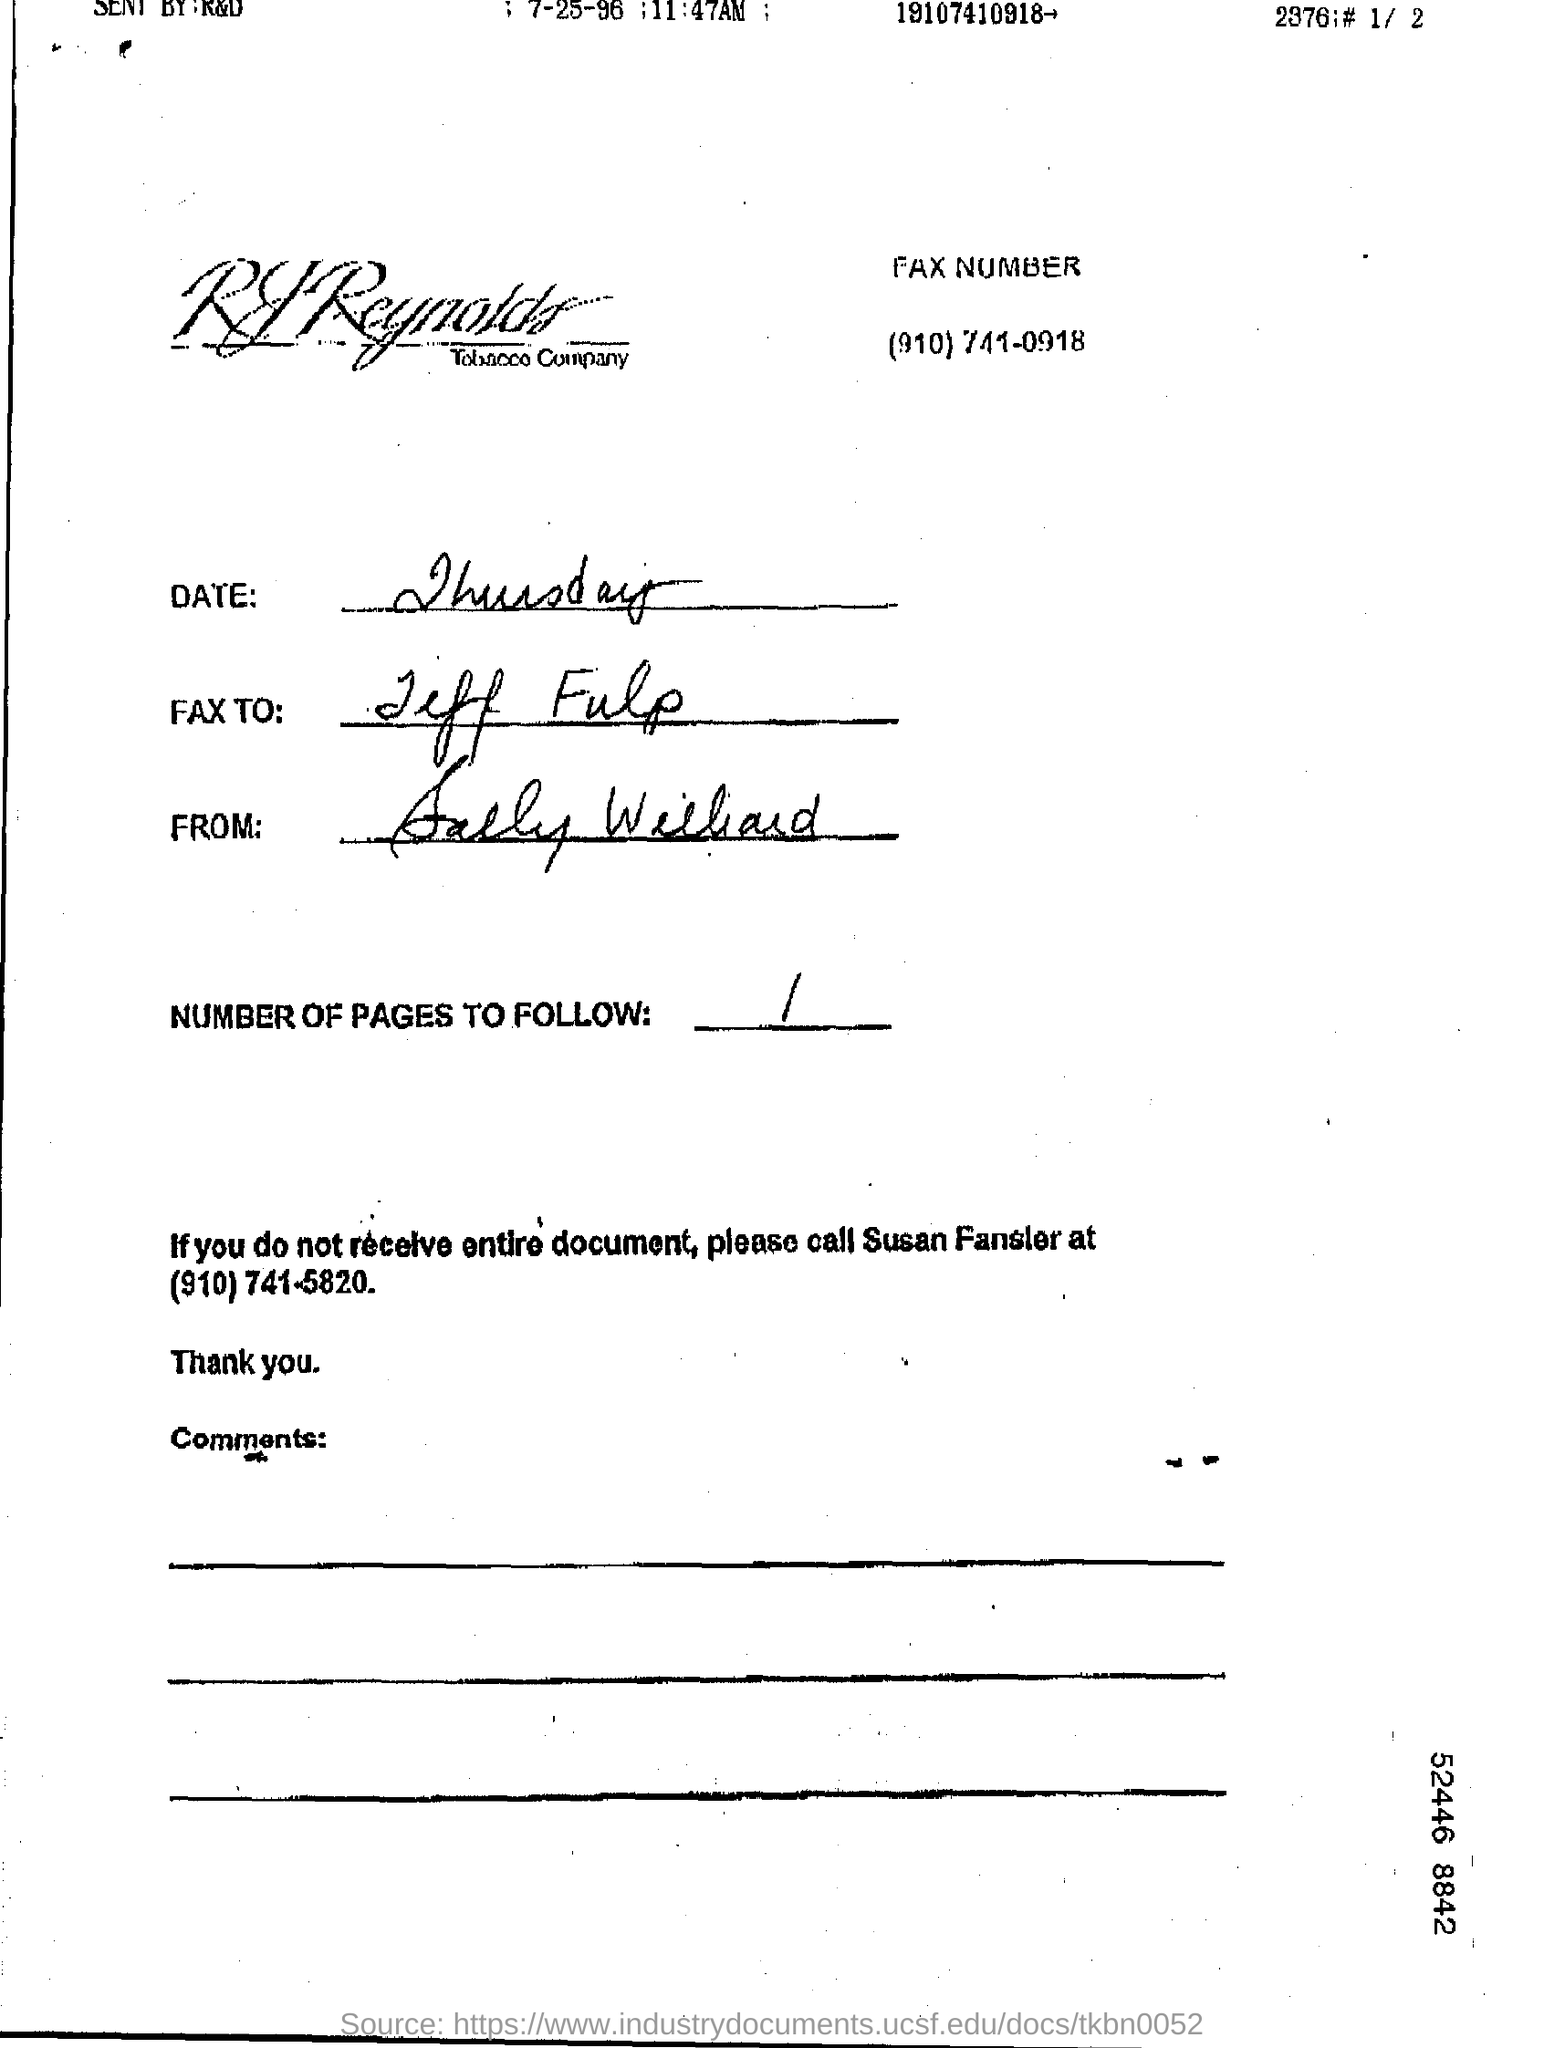What is handwritten as date?
Offer a very short reply. Thursday. Find out the number of page to follow from this page?
Ensure brevity in your answer.  1. 